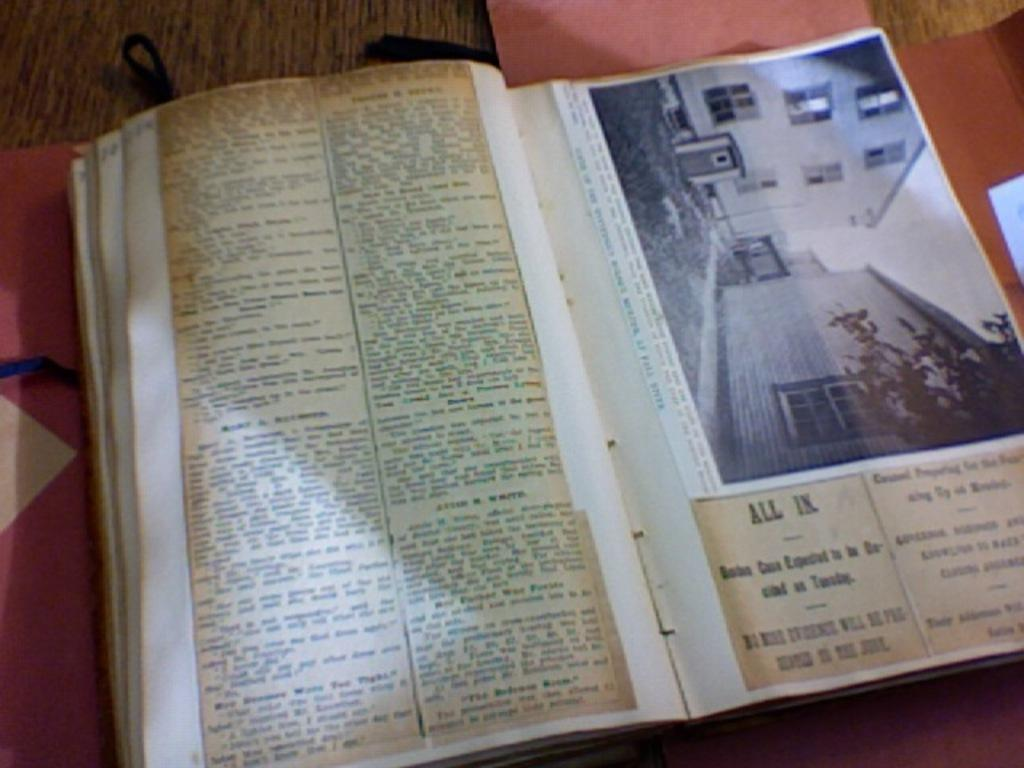<image>
Relay a brief, clear account of the picture shown. A page in a book says all in on it. 